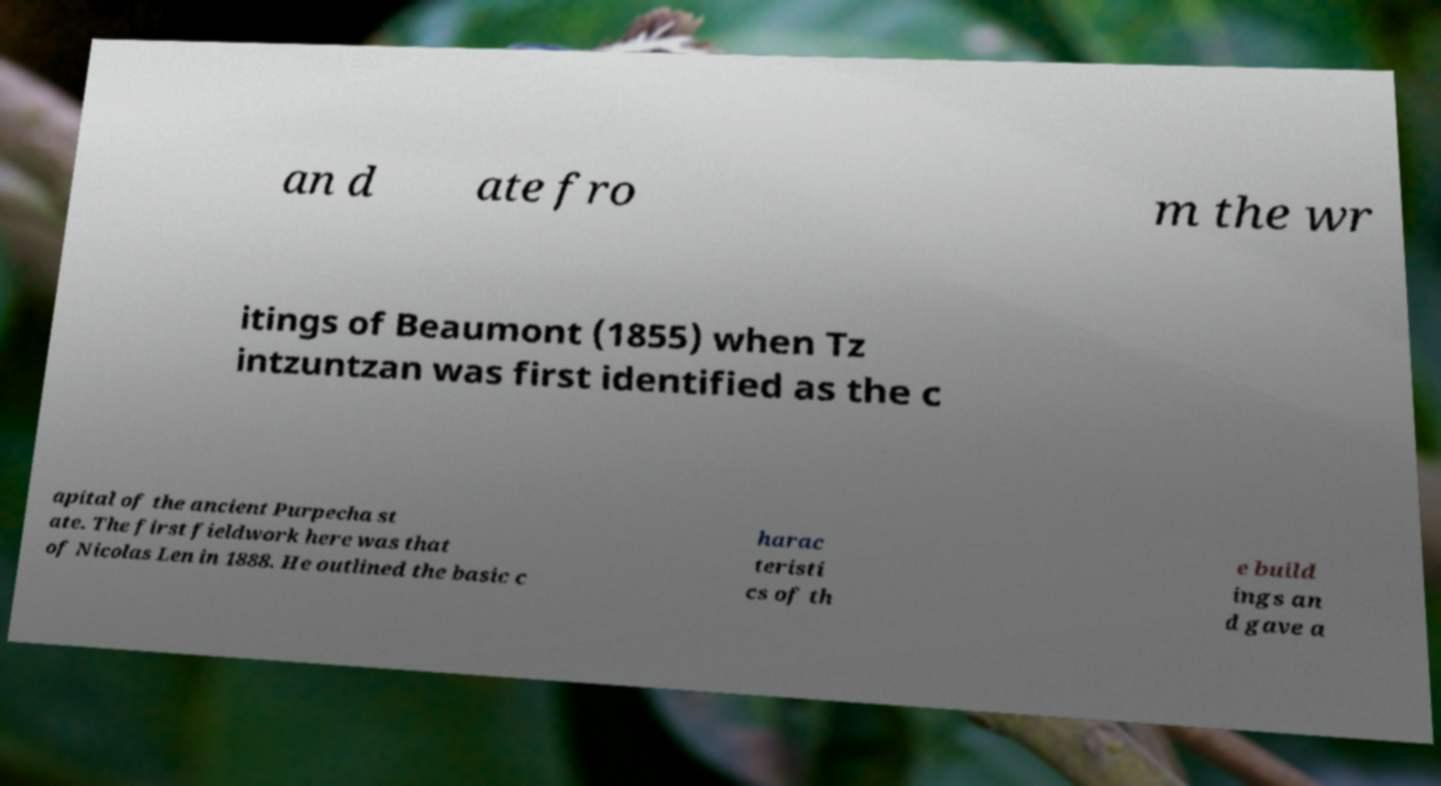Can you read and provide the text displayed in the image?This photo seems to have some interesting text. Can you extract and type it out for me? an d ate fro m the wr itings of Beaumont (1855) when Tz intzuntzan was first identified as the c apital of the ancient Purpecha st ate. The first fieldwork here was that of Nicolas Len in 1888. He outlined the basic c harac teristi cs of th e build ings an d gave a 